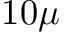Convert formula to latex. <formula><loc_0><loc_0><loc_500><loc_500>1 0 \mu</formula> 